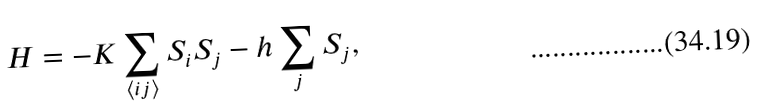<formula> <loc_0><loc_0><loc_500><loc_500>H = - K \sum _ { \langle i j \rangle } S _ { i } S _ { j } - h \sum _ { j } S _ { j } ,</formula> 